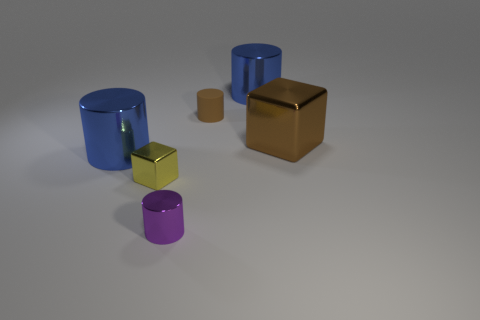There is a thing that is both to the right of the small rubber cylinder and behind the large cube; what material is it?
Your response must be concise. Metal. Is there a shiny block in front of the big metallic thing in front of the shiny cube to the right of the tiny matte cylinder?
Offer a very short reply. Yes. Is there any other thing that is the same material as the brown cylinder?
Your answer should be compact. No. What shape is the tiny purple thing that is made of the same material as the large brown thing?
Give a very brief answer. Cylinder. Is the number of big cylinders behind the brown metal thing less than the number of large cubes that are on the right side of the yellow cube?
Offer a terse response. No. What number of big objects are either yellow metallic objects or brown cylinders?
Your response must be concise. 0. Do the blue metallic thing in front of the large brown shiny object and the blue object that is behind the brown metallic cube have the same shape?
Your answer should be very brief. Yes. There is a block that is in front of the metal thing that is on the left side of the tiny thing that is on the left side of the purple cylinder; what size is it?
Offer a terse response. Small. How big is the block that is behind the yellow shiny thing?
Make the answer very short. Large. There is a blue cylinder that is right of the small metallic block; what is it made of?
Provide a short and direct response. Metal. 